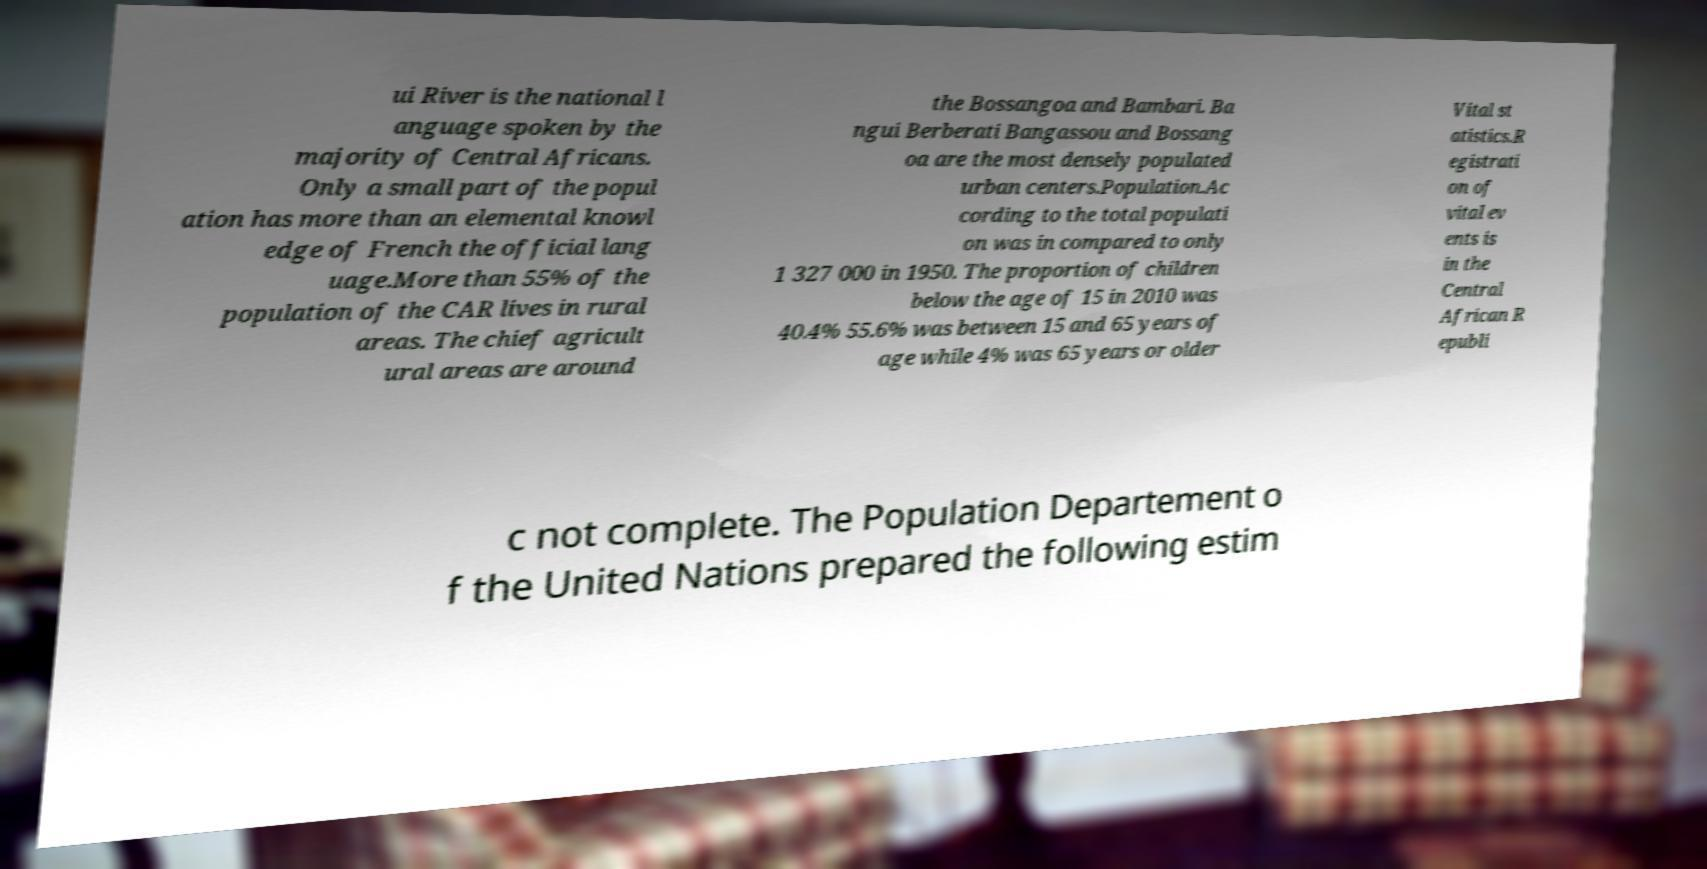Could you extract and type out the text from this image? ui River is the national l anguage spoken by the majority of Central Africans. Only a small part of the popul ation has more than an elemental knowl edge of French the official lang uage.More than 55% of the population of the CAR lives in rural areas. The chief agricult ural areas are around the Bossangoa and Bambari. Ba ngui Berberati Bangassou and Bossang oa are the most densely populated urban centers.Population.Ac cording to the total populati on was in compared to only 1 327 000 in 1950. The proportion of children below the age of 15 in 2010 was 40.4% 55.6% was between 15 and 65 years of age while 4% was 65 years or older Vital st atistics.R egistrati on of vital ev ents is in the Central African R epubli c not complete. The Population Departement o f the United Nations prepared the following estim 